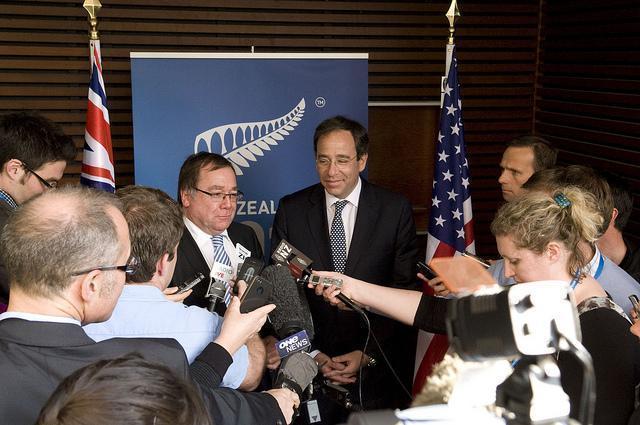What does the NZ on the microphone stand for?
Indicate the correct response by choosing from the four available options to answer the question.
Options: Neutral zone, national-zeitung, net zero, new zealand. New zealand. 